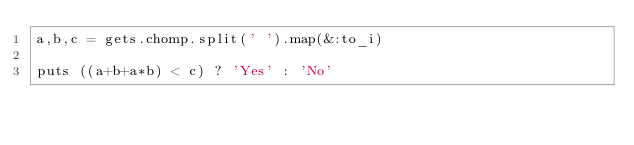<code> <loc_0><loc_0><loc_500><loc_500><_Ruby_>a,b,c = gets.chomp.split(' ').map(&:to_i)

puts ((a+b+a*b) < c) ? 'Yes' : 'No'
</code> 